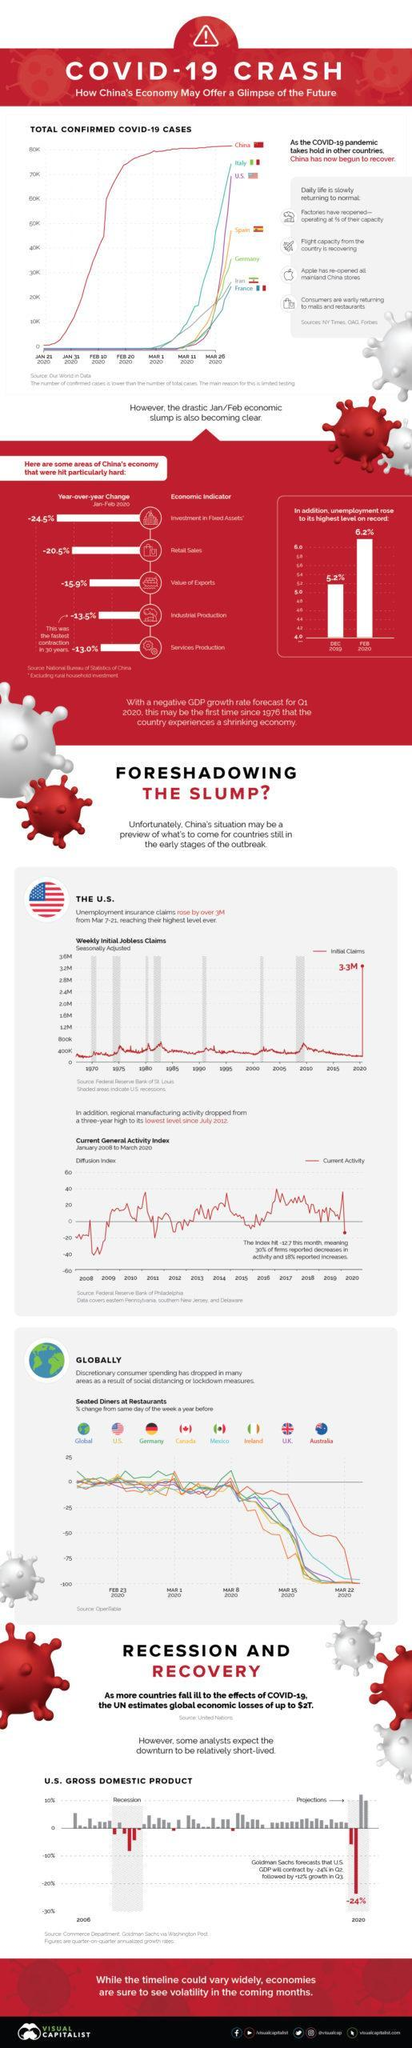What is the difference between the percentage of unemployment rate in Feb and Dec?
Answer the question with a short phrase. 1% 